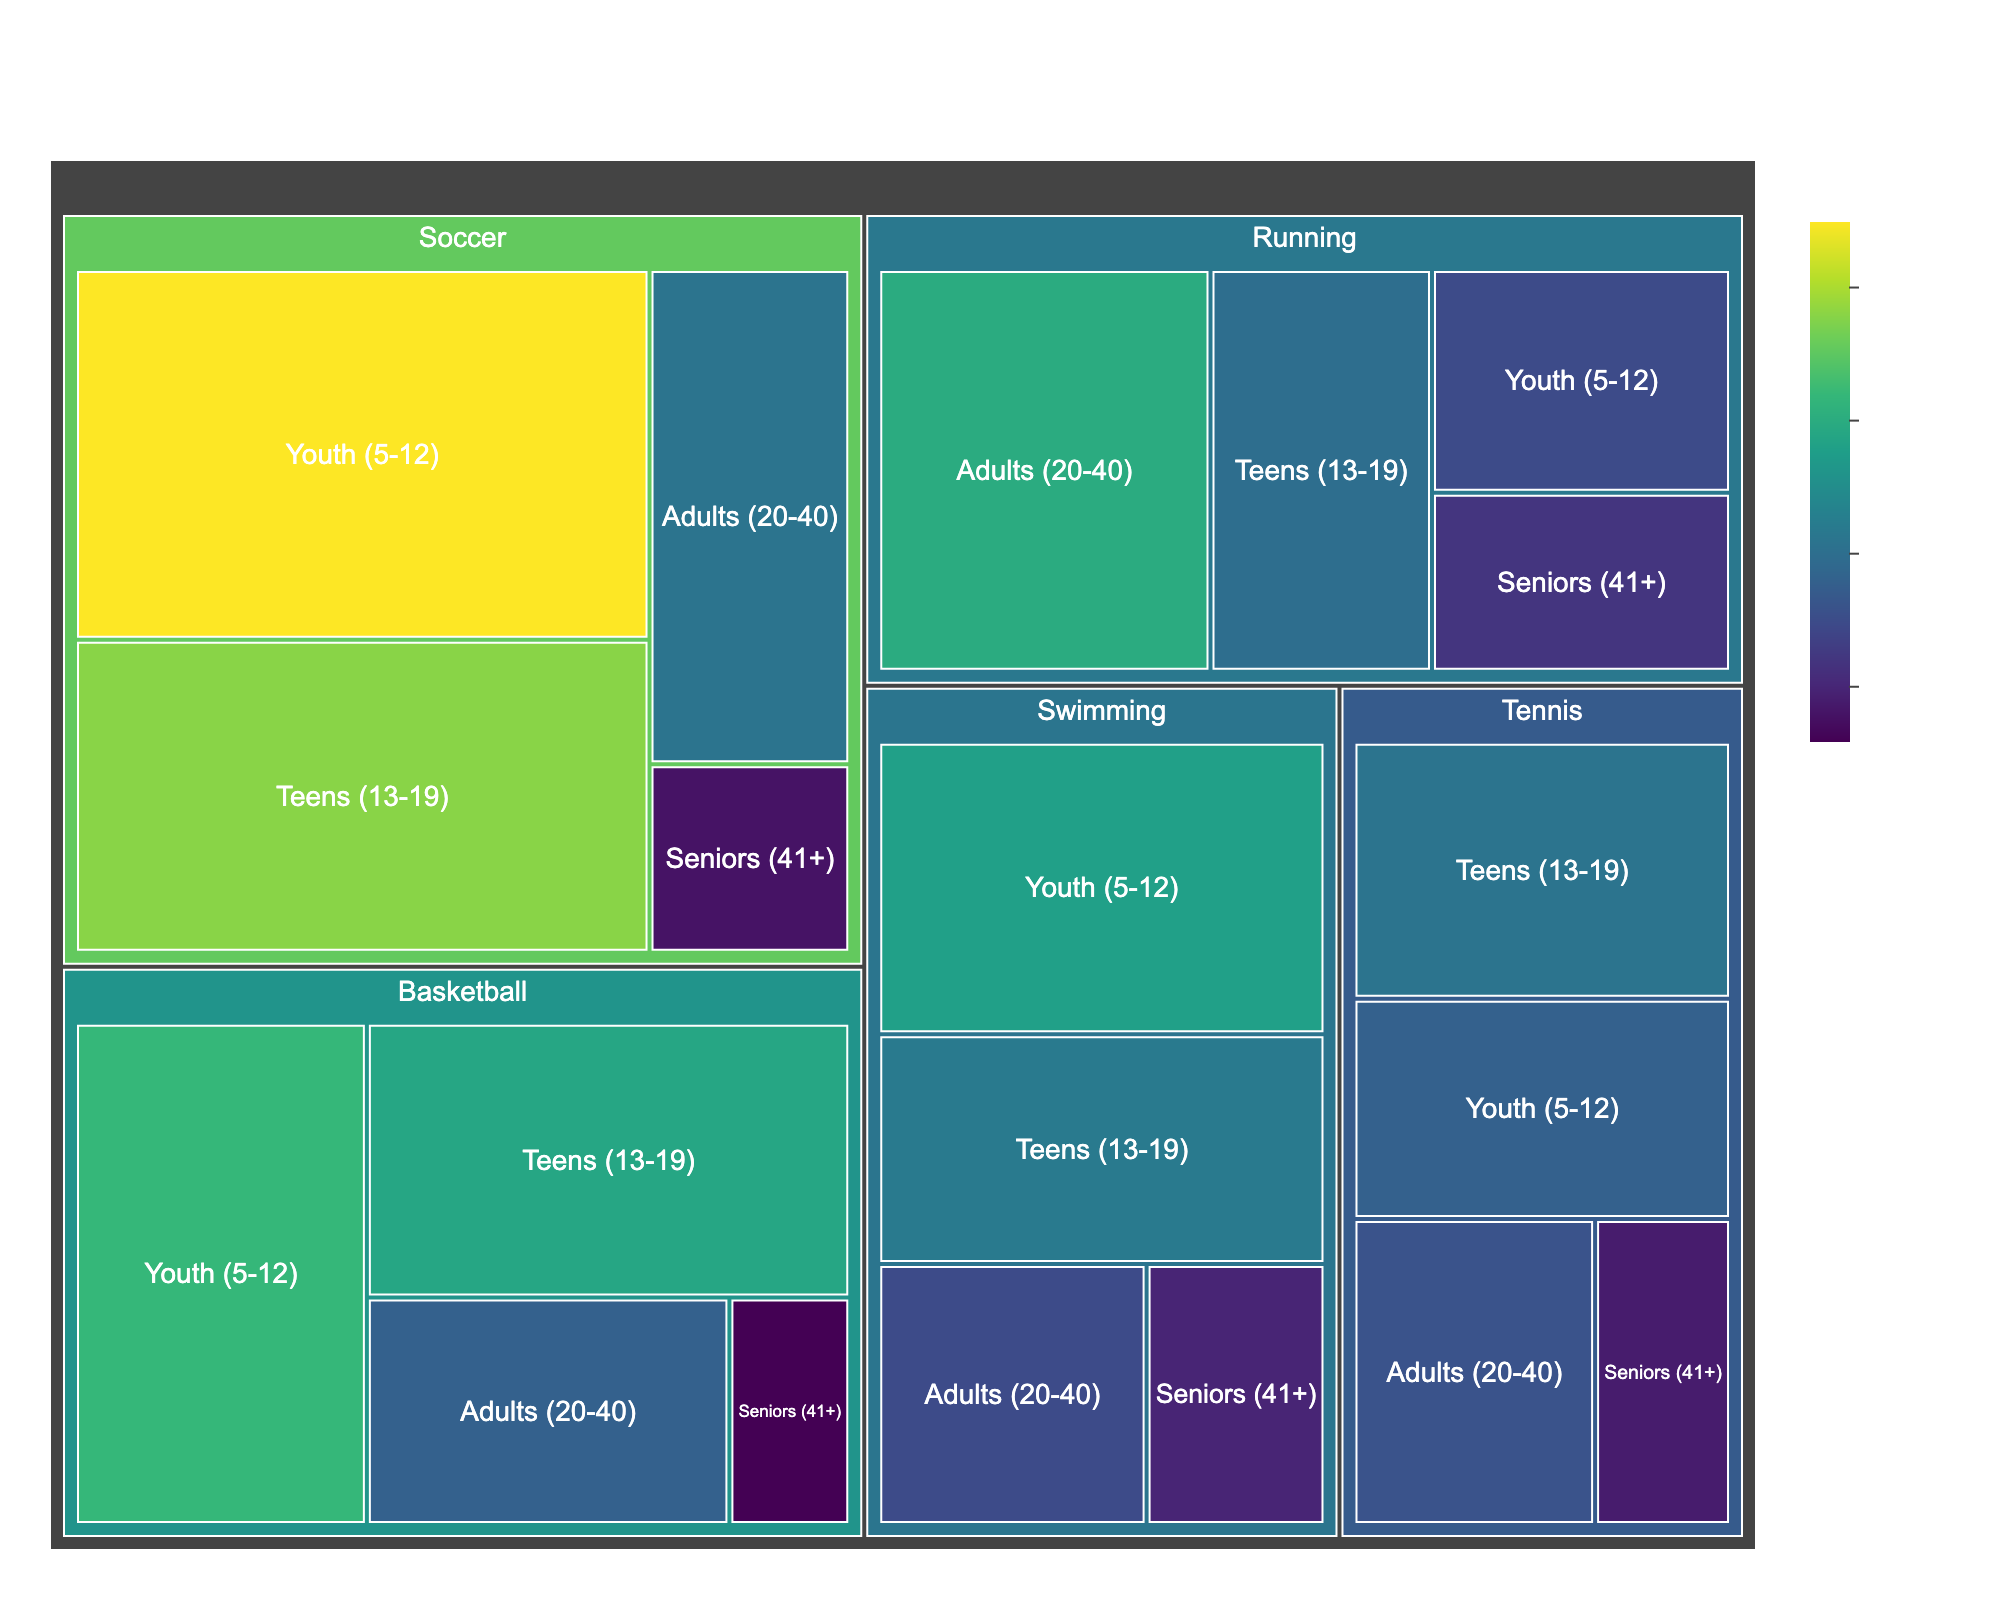What is the sport with the highest number of participants overall? Look at the treemap tiles and identify the sport with the largest total area, which represents the highest number of participants overall.
Answer: Soccer How many participants are there in the "Teens (13-19)" age group for soccer? Locate the tile for the "Teens (13-19)" age group under the Soccer category in the treemap and note the number of participants displayed.
Answer: 380 Which age group has the least participants in Basketball? Identify the smallest tile under the Basketball category in the treemap to find the age group with the least participants.
Answer: Seniors (41+) What's the total number of participants for Swimming across all age groups? Sum the number of participants for each age group under the Swimming category: 280 (Youth) + 220 (Teens) + 150 (Adults) + 100 (Seniors).
Answer: 750 Which sport has more participants in the 'Seniors (41+)' age group, Tennis or Running? Compare the number of participants in the 'Seniors (41+)' age group for Tennis (90) and Running (120).
Answer: Running What is the average number of participants for Tennis across all age groups? Calculate the average by summing up the participants in Tennis (180 + 210 + 160 + 90) and dividing by 4 (number of age groups).
Answer: 160 Which sport has the most evenly distributed number of participants across age groups? Examine the relative sizes of tiles within each sport category to identify the one where all age groups have similarly sized tiles.
Answer: Tennis How many more participants are there in Soccer's 'Youth (5-12)' age group compared to Basketball's 'Teens (13-19)' age group? Subtract the number of participants in Basketball's 'Teens (13-19)' age group (290) from Soccer's 'Youth (5-12)' age group (450).
Answer: 160 Which age group has the highest participation in Running? Identify the largest tile under the Running category in the treemap, which represents the age group with the highest number of participants.
Answer: Adults (20-40) How many total participants are there across all sports and age groups? Sum the number of participants for all the tiles in the treemap.
Answer: 4,480 